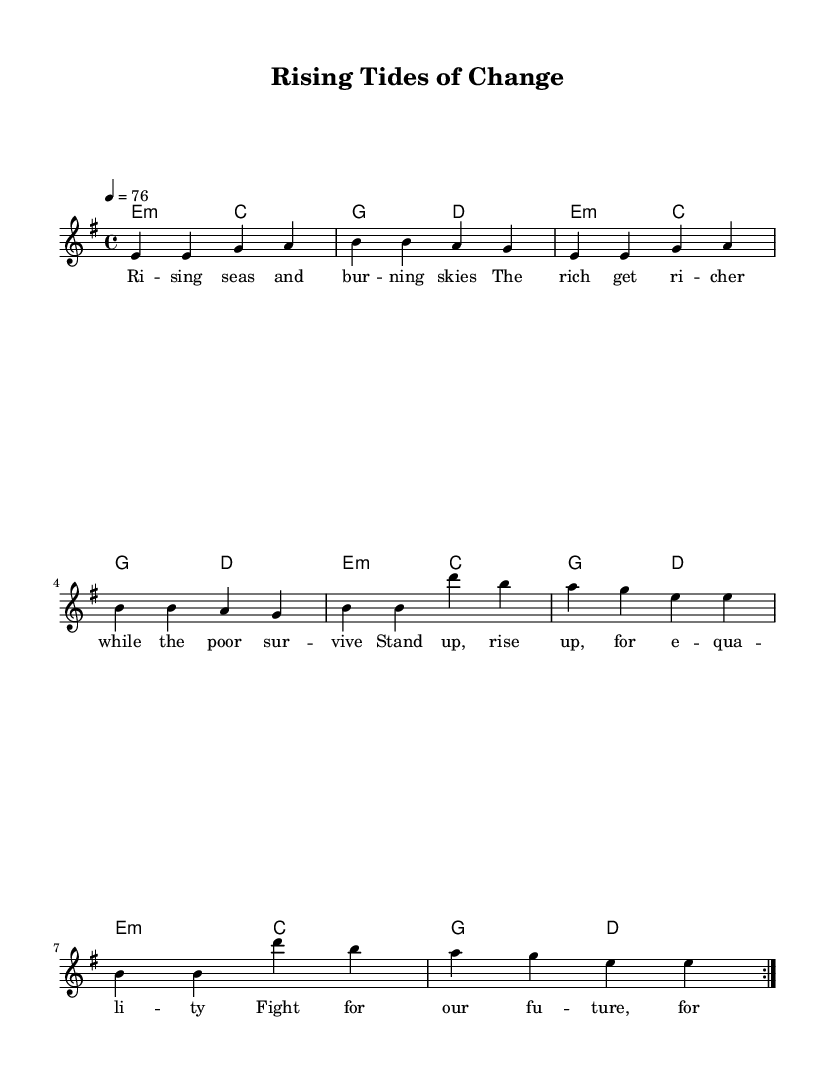What is the key signature of this music? The key signature is indicated by the positioning of sharps and flats at the beginning of the staff. In this case, there are no sharps or flats, and based on the structure of the notes, it is E minor, which is related to G major.
Answer: E minor What is the time signature of this music? The time signature is found at the beginning of the staff, showing how many beats are in each measure. Here, it is 4/4, meaning there are four beats per measure.
Answer: 4/4 What is the tempo marking for this piece? The tempo marking can be found at the beginning where it indicates the speed of the piece. In this score, it shows "4 = 76," meaning there are 76 beats per minute.
Answer: 76 How many measures are repeated in the melody? The repetition of measures can be identified in the score by the "repeat volta" marking. The melody repeats two measures as noted by the "repeat volta 2."
Answer: 2 What is the theme of the lyrics in this piece? The theme can be understood by examining the words under the melody notes. Here, the lyrics talk about rising up against inequality and fighting for a better future. This reflects a focus on social justice and climate change.
Answer: Social justice What type of chords are used in the harmonies section? The harmonies show a particular type of chord based on the chord notations presented. The chords listed include minor and major which are essential characteristics in reggae music. Specifically, the "e2:m" notation indicates E minor and "c2" indicates C major.
Answer: Minor and major Which musical genre does this song belong to? The information about the genre can often be inferred from the content and musical style elements within the piece. Given the thematic lyrics focusing on social issues and the rhythmic pattern typical to the reggae style, it unmistakably belongs to reggae.
Answer: Reggae 